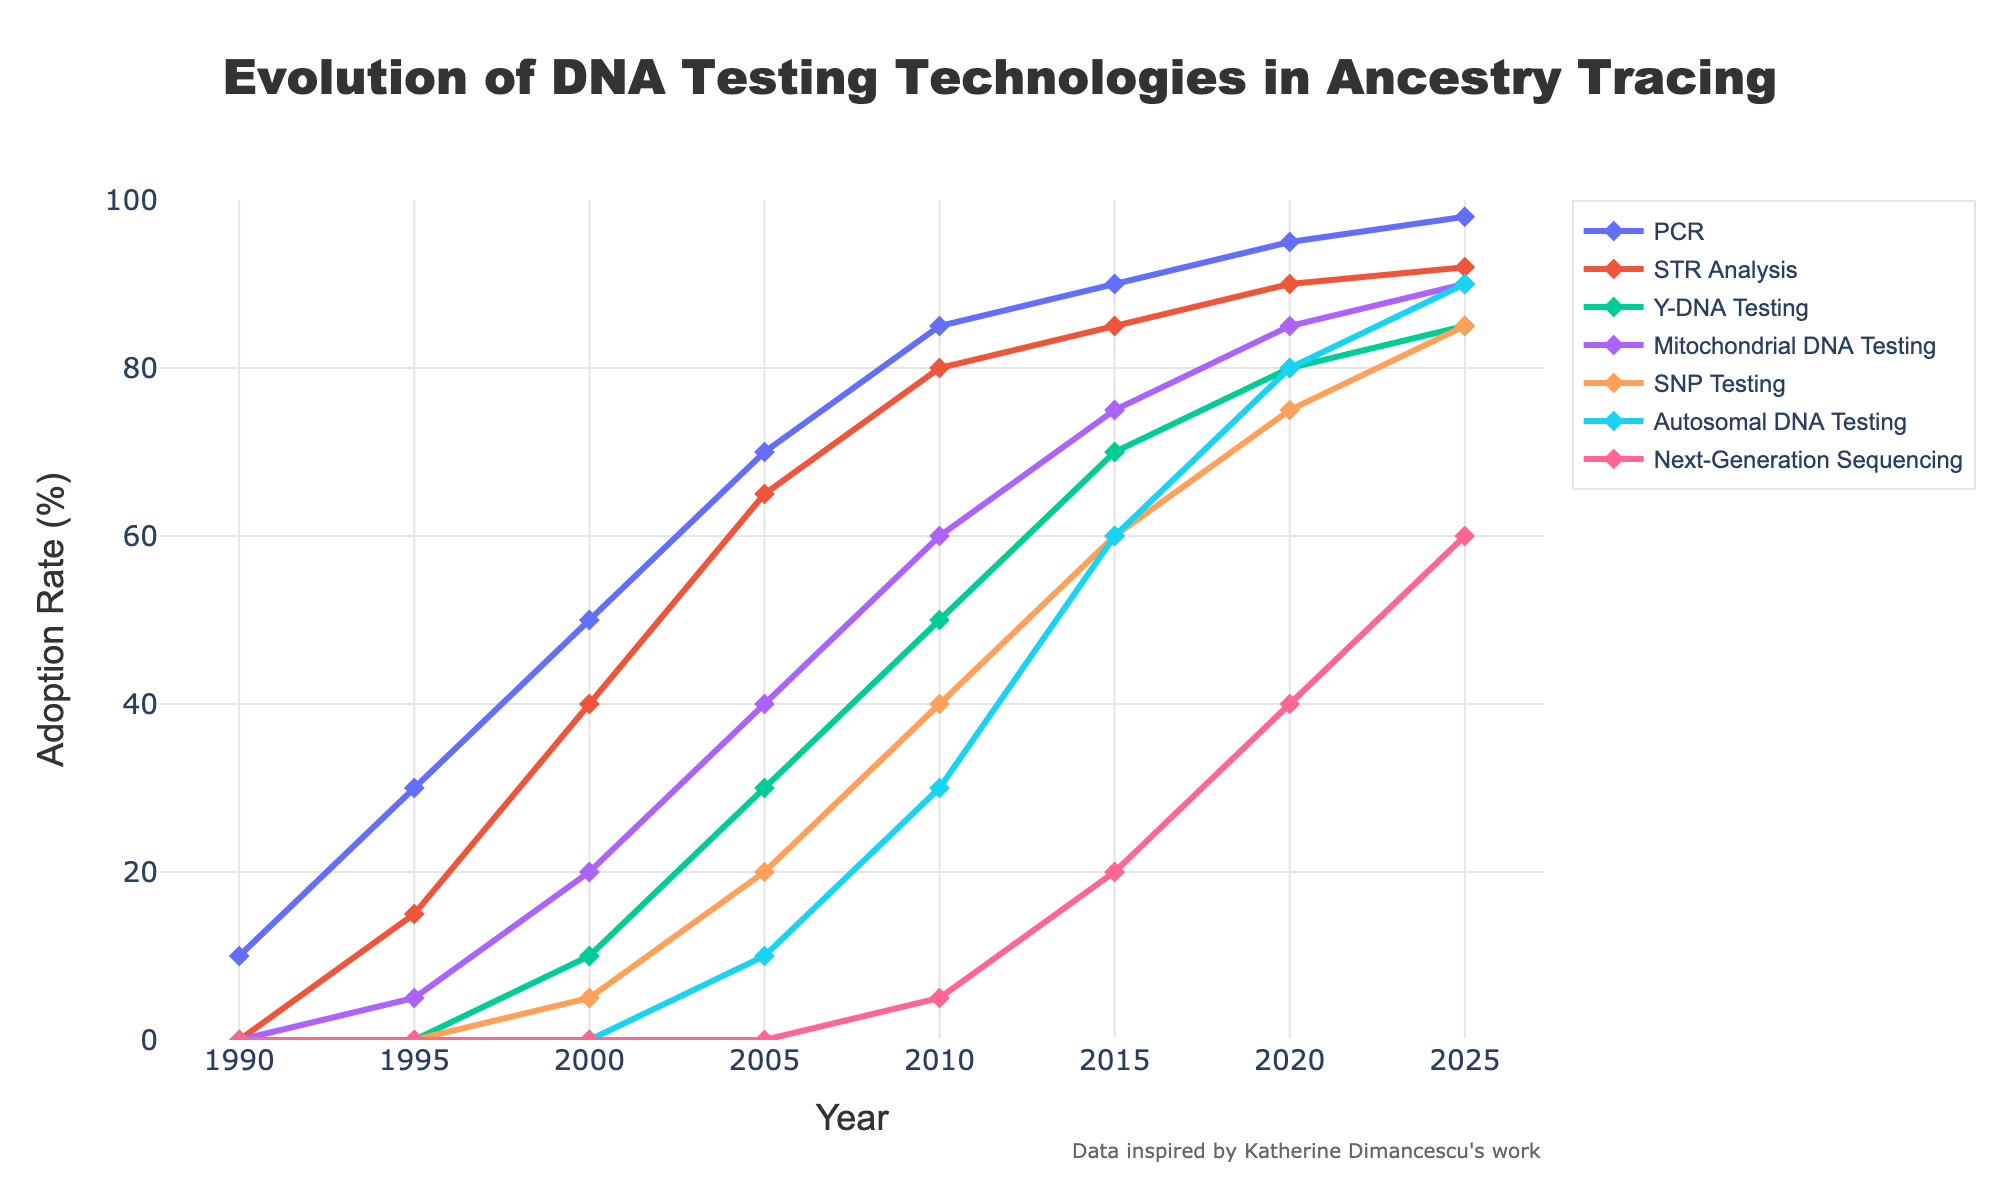Which year does STR Analysis first surpass 50% adoption rate? The figure shows the adoption rate for each technology over time. We need to find the first year where STR Analysis crosses the 50% mark by checking where the line representing STR Analysis surpasses 50%. In 2000, STR Analysis reaches 40%, and 2005, it reaches 65%. Therefore, 2005 is the year it first surpasses 50%.
Answer: 2005 Which DNA testing technology had the sharpest increase in adoption rate from 2015 to 2020? To determine which DNA testing technology has the sharpest increase, we compare the differences in adoption rates from 2015 to 2020 for each technology. PCR increases by 5%, STR Analysis by 5%, Y-DNA Testing by 10%, Mitochondrial DNA Testing by 10%, SNP Testing by 15%, Autosomal DNA Testing by 20%, and Next-Generation Sequencing by 20%. Since Autosomal DNA Testing and Next-Generation Sequencing both increase by 20%, they have the sharpest increase.
Answer: Autosomal DNA Testing and Next-Generation Sequencing What is the combined adoption rate of Y-DNA Testing and Mitochondrial DNA Testing in 2025? We add the adoption rates of Y-DNA Testing and Mitochondrial DNA Testing for the year 2025 from the figure. For Y-DNA Testing, it is 85%, and for Mitochondrial DNA Testing, it is 90%. Adding them gives 85% + 90% = 175%.
Answer: 175% By how much did PCR adoption increase from 1990 to 2000? To find the increase in PCR adoption, we subtract the adoption rate in 1990 from the adoption rate in 2000. PCR adoption in 1990 is 10% and in 2000 is 50%. The increase is 50% - 10% = 40%.
Answer: 40% Which technology had an adoption rate closest to 50% in 2010? We look at the adoption rates for all technologies in the year 2010 and find the one closest to 50%. PCR is 85%, STR Analysis is 80%, Y-DNA Testing is 50%, Mitochondrial DNA Testing is 60%, SNP Testing is 40%, Autosomal DNA Testing is 30%, and Next-Generation Sequencing is 5%. Y-DNA Testing is exactly 50%.
Answer: Y-DNA Testing In which year did Autosomal DNA Testing surpass Mitochondrial DNA Testing in adoption rate? To determine the year when Autosomal DNA Testing surpasses Mitochondrial DNA Testing, we compare their adoption rates year by year. In 2010, Autosomal DNA Testing is 30% and Mitochondrial DNA Testing is 60%. By 2015, Autosomal DNA Testing is 60% and Mitochondrial DNA Testing is 75%. Finally, in 2020, Autosomal DNA Testing is 80% while Mitochondrial DNA Testing is 85%. In 2025, Autosomal DNA Testing is 90% and Mitochondrial DNA Testing is 90%. Autosomal DNA Testing never surpasses Mitochondrial DNA Testing in adoption rate according to the given data.
Answer: Never Does any technology surpass PCR in adoption rate by 2025? If yes, which ones? Examining the adoption rates in 2025, we see that PCR is at 98%. STR Analysis is at 92%, Y-DNA Testing at 85%, Mitochondrial DNA Testing at 90%, SNP Testing at 85%, Autosomal DNA Testing at 90%, and Next-Generation Sequencing at 60%. None of these surpass PCR in adoption rate.
Answer: No What was the cumulative adoption rate for all technologies in the year 2005? To find the cumulative adoption rate for all technologies in 2005, sum the adoption rates of all technologies. PCR is 70%, STR Analysis is 65%, Y-DNA Testing is 30%, Mitochondrial DNA Testing is 40%, SNP Testing is 20%, Autosomal DNA Testing is 10%, and Next-Generation Sequencing is 0%. The sum is 70% + 65% + 30% + 40% + 20% + 10% + 0% = 235%.
Answer: 235% How much did the adoption rate of SNP Testing increase from 2010 to 2025? Subtract the adoption rate of SNP Testing in 2010 from the rate in 2025 to find the increase. The adoption rate in 2010 is 40%, and in 2025 it is 85%. The increase is 85% - 40% = 45%.
Answer: 45% 